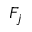Convert formula to latex. <formula><loc_0><loc_0><loc_500><loc_500>F _ { j }</formula> 